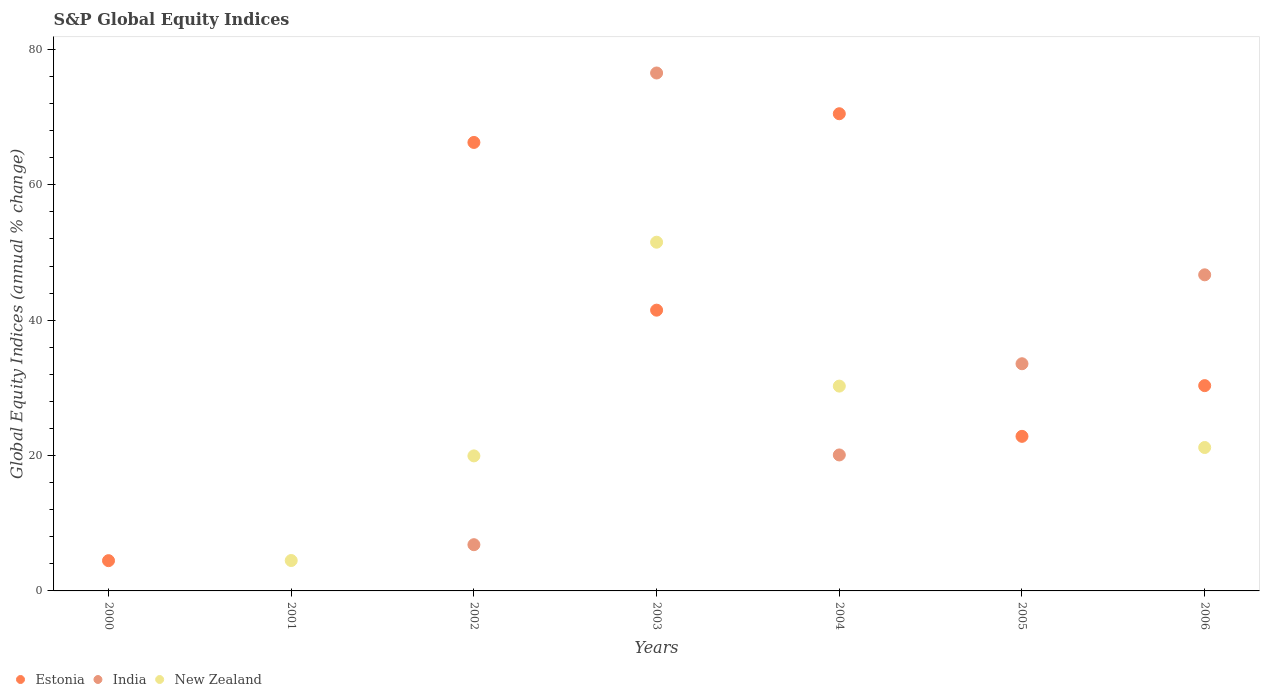Is the number of dotlines equal to the number of legend labels?
Your answer should be compact. No. What is the global equity indices in Estonia in 2005?
Keep it short and to the point. 22.84. Across all years, what is the maximum global equity indices in India?
Provide a succinct answer. 76.52. In which year was the global equity indices in Estonia maximum?
Your answer should be compact. 2004. What is the total global equity indices in Estonia in the graph?
Offer a very short reply. 235.88. What is the difference between the global equity indices in Estonia in 2003 and that in 2006?
Give a very brief answer. 11.15. What is the difference between the global equity indices in New Zealand in 2002 and the global equity indices in India in 2000?
Provide a succinct answer. 19.95. What is the average global equity indices in India per year?
Offer a very short reply. 26.24. In the year 2003, what is the difference between the global equity indices in New Zealand and global equity indices in India?
Offer a terse response. -25. What is the ratio of the global equity indices in Estonia in 2002 to that in 2004?
Give a very brief answer. 0.94. Is the difference between the global equity indices in New Zealand in 2002 and 2003 greater than the difference between the global equity indices in India in 2002 and 2003?
Offer a terse response. Yes. What is the difference between the highest and the second highest global equity indices in India?
Keep it short and to the point. 29.82. What is the difference between the highest and the lowest global equity indices in New Zealand?
Give a very brief answer. 51.52. Does the global equity indices in Estonia monotonically increase over the years?
Make the answer very short. No. Is the global equity indices in India strictly greater than the global equity indices in Estonia over the years?
Make the answer very short. No. Is the global equity indices in Estonia strictly less than the global equity indices in New Zealand over the years?
Your answer should be compact. No. How many dotlines are there?
Your response must be concise. 3. How many years are there in the graph?
Your answer should be compact. 7. Are the values on the major ticks of Y-axis written in scientific E-notation?
Provide a short and direct response. No. Does the graph contain grids?
Your answer should be very brief. No. What is the title of the graph?
Your response must be concise. S&P Global Equity Indices. What is the label or title of the X-axis?
Provide a short and direct response. Years. What is the label or title of the Y-axis?
Your answer should be compact. Global Equity Indices (annual % change). What is the Global Equity Indices (annual % change) of Estonia in 2000?
Ensure brevity in your answer.  4.47. What is the Global Equity Indices (annual % change) of India in 2000?
Ensure brevity in your answer.  0. What is the Global Equity Indices (annual % change) in New Zealand in 2000?
Ensure brevity in your answer.  0. What is the Global Equity Indices (annual % change) of New Zealand in 2001?
Provide a short and direct response. 4.49. What is the Global Equity Indices (annual % change) of Estonia in 2002?
Provide a succinct answer. 66.26. What is the Global Equity Indices (annual % change) in India in 2002?
Your response must be concise. 6.83. What is the Global Equity Indices (annual % change) in New Zealand in 2002?
Keep it short and to the point. 19.95. What is the Global Equity Indices (annual % change) in Estonia in 2003?
Give a very brief answer. 41.48. What is the Global Equity Indices (annual % change) of India in 2003?
Your response must be concise. 76.52. What is the Global Equity Indices (annual % change) in New Zealand in 2003?
Offer a very short reply. 51.52. What is the Global Equity Indices (annual % change) of Estonia in 2004?
Your answer should be compact. 70.5. What is the Global Equity Indices (annual % change) of India in 2004?
Give a very brief answer. 20.09. What is the Global Equity Indices (annual % change) in New Zealand in 2004?
Your response must be concise. 30.26. What is the Global Equity Indices (annual % change) in Estonia in 2005?
Keep it short and to the point. 22.84. What is the Global Equity Indices (annual % change) in India in 2005?
Keep it short and to the point. 33.56. What is the Global Equity Indices (annual % change) of Estonia in 2006?
Offer a very short reply. 30.33. What is the Global Equity Indices (annual % change) of India in 2006?
Ensure brevity in your answer.  46.7. What is the Global Equity Indices (annual % change) in New Zealand in 2006?
Provide a succinct answer. 21.19. Across all years, what is the maximum Global Equity Indices (annual % change) of Estonia?
Ensure brevity in your answer.  70.5. Across all years, what is the maximum Global Equity Indices (annual % change) of India?
Keep it short and to the point. 76.52. Across all years, what is the maximum Global Equity Indices (annual % change) in New Zealand?
Give a very brief answer. 51.52. Across all years, what is the minimum Global Equity Indices (annual % change) of Estonia?
Offer a very short reply. 0. Across all years, what is the minimum Global Equity Indices (annual % change) in New Zealand?
Ensure brevity in your answer.  0. What is the total Global Equity Indices (annual % change) of Estonia in the graph?
Make the answer very short. 235.88. What is the total Global Equity Indices (annual % change) in India in the graph?
Your response must be concise. 183.7. What is the total Global Equity Indices (annual % change) in New Zealand in the graph?
Keep it short and to the point. 127.41. What is the difference between the Global Equity Indices (annual % change) in Estonia in 2000 and that in 2002?
Your answer should be very brief. -61.79. What is the difference between the Global Equity Indices (annual % change) of Estonia in 2000 and that in 2003?
Keep it short and to the point. -37.01. What is the difference between the Global Equity Indices (annual % change) in Estonia in 2000 and that in 2004?
Offer a terse response. -66.03. What is the difference between the Global Equity Indices (annual % change) in Estonia in 2000 and that in 2005?
Your response must be concise. -18.37. What is the difference between the Global Equity Indices (annual % change) in Estonia in 2000 and that in 2006?
Your answer should be very brief. -25.86. What is the difference between the Global Equity Indices (annual % change) of New Zealand in 2001 and that in 2002?
Your response must be concise. -15.46. What is the difference between the Global Equity Indices (annual % change) of New Zealand in 2001 and that in 2003?
Make the answer very short. -47.03. What is the difference between the Global Equity Indices (annual % change) of New Zealand in 2001 and that in 2004?
Offer a terse response. -25.77. What is the difference between the Global Equity Indices (annual % change) of New Zealand in 2001 and that in 2006?
Make the answer very short. -16.7. What is the difference between the Global Equity Indices (annual % change) of Estonia in 2002 and that in 2003?
Your answer should be compact. 24.78. What is the difference between the Global Equity Indices (annual % change) in India in 2002 and that in 2003?
Ensure brevity in your answer.  -69.69. What is the difference between the Global Equity Indices (annual % change) in New Zealand in 2002 and that in 2003?
Your answer should be compact. -31.57. What is the difference between the Global Equity Indices (annual % change) of Estonia in 2002 and that in 2004?
Offer a very short reply. -4.24. What is the difference between the Global Equity Indices (annual % change) of India in 2002 and that in 2004?
Your answer should be very brief. -13.26. What is the difference between the Global Equity Indices (annual % change) of New Zealand in 2002 and that in 2004?
Your answer should be compact. -10.31. What is the difference between the Global Equity Indices (annual % change) in Estonia in 2002 and that in 2005?
Give a very brief answer. 43.42. What is the difference between the Global Equity Indices (annual % change) in India in 2002 and that in 2005?
Ensure brevity in your answer.  -26.73. What is the difference between the Global Equity Indices (annual % change) of Estonia in 2002 and that in 2006?
Provide a succinct answer. 35.93. What is the difference between the Global Equity Indices (annual % change) of India in 2002 and that in 2006?
Ensure brevity in your answer.  -39.87. What is the difference between the Global Equity Indices (annual % change) of New Zealand in 2002 and that in 2006?
Offer a very short reply. -1.24. What is the difference between the Global Equity Indices (annual % change) of Estonia in 2003 and that in 2004?
Offer a very short reply. -29.02. What is the difference between the Global Equity Indices (annual % change) of India in 2003 and that in 2004?
Your answer should be very brief. 56.43. What is the difference between the Global Equity Indices (annual % change) in New Zealand in 2003 and that in 2004?
Your response must be concise. 21.26. What is the difference between the Global Equity Indices (annual % change) in Estonia in 2003 and that in 2005?
Give a very brief answer. 18.64. What is the difference between the Global Equity Indices (annual % change) of India in 2003 and that in 2005?
Give a very brief answer. 42.96. What is the difference between the Global Equity Indices (annual % change) of Estonia in 2003 and that in 2006?
Provide a succinct answer. 11.15. What is the difference between the Global Equity Indices (annual % change) of India in 2003 and that in 2006?
Provide a succinct answer. 29.82. What is the difference between the Global Equity Indices (annual % change) in New Zealand in 2003 and that in 2006?
Offer a very short reply. 30.33. What is the difference between the Global Equity Indices (annual % change) of Estonia in 2004 and that in 2005?
Your answer should be very brief. 47.66. What is the difference between the Global Equity Indices (annual % change) of India in 2004 and that in 2005?
Provide a succinct answer. -13.47. What is the difference between the Global Equity Indices (annual % change) of Estonia in 2004 and that in 2006?
Provide a short and direct response. 40.17. What is the difference between the Global Equity Indices (annual % change) in India in 2004 and that in 2006?
Provide a succinct answer. -26.61. What is the difference between the Global Equity Indices (annual % change) of New Zealand in 2004 and that in 2006?
Keep it short and to the point. 9.07. What is the difference between the Global Equity Indices (annual % change) of Estonia in 2005 and that in 2006?
Offer a very short reply. -7.49. What is the difference between the Global Equity Indices (annual % change) of India in 2005 and that in 2006?
Give a very brief answer. -13.14. What is the difference between the Global Equity Indices (annual % change) of Estonia in 2000 and the Global Equity Indices (annual % change) of New Zealand in 2001?
Your response must be concise. -0.02. What is the difference between the Global Equity Indices (annual % change) of Estonia in 2000 and the Global Equity Indices (annual % change) of India in 2002?
Make the answer very short. -2.36. What is the difference between the Global Equity Indices (annual % change) in Estonia in 2000 and the Global Equity Indices (annual % change) in New Zealand in 2002?
Keep it short and to the point. -15.48. What is the difference between the Global Equity Indices (annual % change) in Estonia in 2000 and the Global Equity Indices (annual % change) in India in 2003?
Provide a short and direct response. -72.05. What is the difference between the Global Equity Indices (annual % change) of Estonia in 2000 and the Global Equity Indices (annual % change) of New Zealand in 2003?
Give a very brief answer. -47.05. What is the difference between the Global Equity Indices (annual % change) of Estonia in 2000 and the Global Equity Indices (annual % change) of India in 2004?
Keep it short and to the point. -15.62. What is the difference between the Global Equity Indices (annual % change) of Estonia in 2000 and the Global Equity Indices (annual % change) of New Zealand in 2004?
Your answer should be compact. -25.79. What is the difference between the Global Equity Indices (annual % change) of Estonia in 2000 and the Global Equity Indices (annual % change) of India in 2005?
Provide a short and direct response. -29.09. What is the difference between the Global Equity Indices (annual % change) of Estonia in 2000 and the Global Equity Indices (annual % change) of India in 2006?
Offer a very short reply. -42.23. What is the difference between the Global Equity Indices (annual % change) in Estonia in 2000 and the Global Equity Indices (annual % change) in New Zealand in 2006?
Ensure brevity in your answer.  -16.72. What is the difference between the Global Equity Indices (annual % change) in Estonia in 2002 and the Global Equity Indices (annual % change) in India in 2003?
Keep it short and to the point. -10.26. What is the difference between the Global Equity Indices (annual % change) of Estonia in 2002 and the Global Equity Indices (annual % change) of New Zealand in 2003?
Ensure brevity in your answer.  14.74. What is the difference between the Global Equity Indices (annual % change) in India in 2002 and the Global Equity Indices (annual % change) in New Zealand in 2003?
Make the answer very short. -44.69. What is the difference between the Global Equity Indices (annual % change) in Estonia in 2002 and the Global Equity Indices (annual % change) in India in 2004?
Offer a very short reply. 46.17. What is the difference between the Global Equity Indices (annual % change) in Estonia in 2002 and the Global Equity Indices (annual % change) in New Zealand in 2004?
Make the answer very short. 36. What is the difference between the Global Equity Indices (annual % change) in India in 2002 and the Global Equity Indices (annual % change) in New Zealand in 2004?
Give a very brief answer. -23.43. What is the difference between the Global Equity Indices (annual % change) of Estonia in 2002 and the Global Equity Indices (annual % change) of India in 2005?
Provide a short and direct response. 32.7. What is the difference between the Global Equity Indices (annual % change) in Estonia in 2002 and the Global Equity Indices (annual % change) in India in 2006?
Give a very brief answer. 19.56. What is the difference between the Global Equity Indices (annual % change) in Estonia in 2002 and the Global Equity Indices (annual % change) in New Zealand in 2006?
Keep it short and to the point. 45.07. What is the difference between the Global Equity Indices (annual % change) of India in 2002 and the Global Equity Indices (annual % change) of New Zealand in 2006?
Your response must be concise. -14.36. What is the difference between the Global Equity Indices (annual % change) in Estonia in 2003 and the Global Equity Indices (annual % change) in India in 2004?
Make the answer very short. 21.39. What is the difference between the Global Equity Indices (annual % change) of Estonia in 2003 and the Global Equity Indices (annual % change) of New Zealand in 2004?
Offer a very short reply. 11.22. What is the difference between the Global Equity Indices (annual % change) in India in 2003 and the Global Equity Indices (annual % change) in New Zealand in 2004?
Offer a terse response. 46.26. What is the difference between the Global Equity Indices (annual % change) of Estonia in 2003 and the Global Equity Indices (annual % change) of India in 2005?
Your answer should be compact. 7.92. What is the difference between the Global Equity Indices (annual % change) in Estonia in 2003 and the Global Equity Indices (annual % change) in India in 2006?
Offer a terse response. -5.22. What is the difference between the Global Equity Indices (annual % change) of Estonia in 2003 and the Global Equity Indices (annual % change) of New Zealand in 2006?
Your answer should be very brief. 20.29. What is the difference between the Global Equity Indices (annual % change) in India in 2003 and the Global Equity Indices (annual % change) in New Zealand in 2006?
Offer a terse response. 55.33. What is the difference between the Global Equity Indices (annual % change) in Estonia in 2004 and the Global Equity Indices (annual % change) in India in 2005?
Give a very brief answer. 36.94. What is the difference between the Global Equity Indices (annual % change) in Estonia in 2004 and the Global Equity Indices (annual % change) in India in 2006?
Offer a very short reply. 23.8. What is the difference between the Global Equity Indices (annual % change) in Estonia in 2004 and the Global Equity Indices (annual % change) in New Zealand in 2006?
Provide a short and direct response. 49.31. What is the difference between the Global Equity Indices (annual % change) of India in 2004 and the Global Equity Indices (annual % change) of New Zealand in 2006?
Your answer should be compact. -1.1. What is the difference between the Global Equity Indices (annual % change) in Estonia in 2005 and the Global Equity Indices (annual % change) in India in 2006?
Provide a succinct answer. -23.86. What is the difference between the Global Equity Indices (annual % change) in Estonia in 2005 and the Global Equity Indices (annual % change) in New Zealand in 2006?
Keep it short and to the point. 1.65. What is the difference between the Global Equity Indices (annual % change) of India in 2005 and the Global Equity Indices (annual % change) of New Zealand in 2006?
Your answer should be compact. 12.37. What is the average Global Equity Indices (annual % change) in Estonia per year?
Your response must be concise. 33.7. What is the average Global Equity Indices (annual % change) in India per year?
Make the answer very short. 26.24. What is the average Global Equity Indices (annual % change) in New Zealand per year?
Your answer should be very brief. 18.2. In the year 2002, what is the difference between the Global Equity Indices (annual % change) of Estonia and Global Equity Indices (annual % change) of India?
Your answer should be very brief. 59.43. In the year 2002, what is the difference between the Global Equity Indices (annual % change) of Estonia and Global Equity Indices (annual % change) of New Zealand?
Provide a short and direct response. 46.31. In the year 2002, what is the difference between the Global Equity Indices (annual % change) of India and Global Equity Indices (annual % change) of New Zealand?
Provide a succinct answer. -13.12. In the year 2003, what is the difference between the Global Equity Indices (annual % change) in Estonia and Global Equity Indices (annual % change) in India?
Make the answer very short. -35.04. In the year 2003, what is the difference between the Global Equity Indices (annual % change) of Estonia and Global Equity Indices (annual % change) of New Zealand?
Your answer should be compact. -10.04. In the year 2003, what is the difference between the Global Equity Indices (annual % change) of India and Global Equity Indices (annual % change) of New Zealand?
Provide a short and direct response. 25. In the year 2004, what is the difference between the Global Equity Indices (annual % change) in Estonia and Global Equity Indices (annual % change) in India?
Provide a succinct answer. 50.41. In the year 2004, what is the difference between the Global Equity Indices (annual % change) of Estonia and Global Equity Indices (annual % change) of New Zealand?
Provide a succinct answer. 40.24. In the year 2004, what is the difference between the Global Equity Indices (annual % change) in India and Global Equity Indices (annual % change) in New Zealand?
Your response must be concise. -10.17. In the year 2005, what is the difference between the Global Equity Indices (annual % change) of Estonia and Global Equity Indices (annual % change) of India?
Keep it short and to the point. -10.73. In the year 2006, what is the difference between the Global Equity Indices (annual % change) in Estonia and Global Equity Indices (annual % change) in India?
Provide a short and direct response. -16.37. In the year 2006, what is the difference between the Global Equity Indices (annual % change) in Estonia and Global Equity Indices (annual % change) in New Zealand?
Make the answer very short. 9.14. In the year 2006, what is the difference between the Global Equity Indices (annual % change) of India and Global Equity Indices (annual % change) of New Zealand?
Your response must be concise. 25.51. What is the ratio of the Global Equity Indices (annual % change) of Estonia in 2000 to that in 2002?
Provide a succinct answer. 0.07. What is the ratio of the Global Equity Indices (annual % change) of Estonia in 2000 to that in 2003?
Make the answer very short. 0.11. What is the ratio of the Global Equity Indices (annual % change) in Estonia in 2000 to that in 2004?
Provide a succinct answer. 0.06. What is the ratio of the Global Equity Indices (annual % change) in Estonia in 2000 to that in 2005?
Your answer should be very brief. 0.2. What is the ratio of the Global Equity Indices (annual % change) in Estonia in 2000 to that in 2006?
Provide a short and direct response. 0.15. What is the ratio of the Global Equity Indices (annual % change) in New Zealand in 2001 to that in 2002?
Provide a short and direct response. 0.23. What is the ratio of the Global Equity Indices (annual % change) of New Zealand in 2001 to that in 2003?
Keep it short and to the point. 0.09. What is the ratio of the Global Equity Indices (annual % change) of New Zealand in 2001 to that in 2004?
Provide a succinct answer. 0.15. What is the ratio of the Global Equity Indices (annual % change) of New Zealand in 2001 to that in 2006?
Offer a terse response. 0.21. What is the ratio of the Global Equity Indices (annual % change) of Estonia in 2002 to that in 2003?
Your answer should be compact. 1.6. What is the ratio of the Global Equity Indices (annual % change) in India in 2002 to that in 2003?
Offer a very short reply. 0.09. What is the ratio of the Global Equity Indices (annual % change) in New Zealand in 2002 to that in 2003?
Keep it short and to the point. 0.39. What is the ratio of the Global Equity Indices (annual % change) of Estonia in 2002 to that in 2004?
Offer a terse response. 0.94. What is the ratio of the Global Equity Indices (annual % change) in India in 2002 to that in 2004?
Give a very brief answer. 0.34. What is the ratio of the Global Equity Indices (annual % change) of New Zealand in 2002 to that in 2004?
Make the answer very short. 0.66. What is the ratio of the Global Equity Indices (annual % change) of Estonia in 2002 to that in 2005?
Give a very brief answer. 2.9. What is the ratio of the Global Equity Indices (annual % change) of India in 2002 to that in 2005?
Keep it short and to the point. 0.2. What is the ratio of the Global Equity Indices (annual % change) in Estonia in 2002 to that in 2006?
Your response must be concise. 2.18. What is the ratio of the Global Equity Indices (annual % change) of India in 2002 to that in 2006?
Make the answer very short. 0.15. What is the ratio of the Global Equity Indices (annual % change) in New Zealand in 2002 to that in 2006?
Offer a terse response. 0.94. What is the ratio of the Global Equity Indices (annual % change) in Estonia in 2003 to that in 2004?
Provide a succinct answer. 0.59. What is the ratio of the Global Equity Indices (annual % change) in India in 2003 to that in 2004?
Offer a terse response. 3.81. What is the ratio of the Global Equity Indices (annual % change) of New Zealand in 2003 to that in 2004?
Give a very brief answer. 1.7. What is the ratio of the Global Equity Indices (annual % change) in Estonia in 2003 to that in 2005?
Keep it short and to the point. 1.82. What is the ratio of the Global Equity Indices (annual % change) of India in 2003 to that in 2005?
Offer a very short reply. 2.28. What is the ratio of the Global Equity Indices (annual % change) in Estonia in 2003 to that in 2006?
Keep it short and to the point. 1.37. What is the ratio of the Global Equity Indices (annual % change) of India in 2003 to that in 2006?
Keep it short and to the point. 1.64. What is the ratio of the Global Equity Indices (annual % change) of New Zealand in 2003 to that in 2006?
Your response must be concise. 2.43. What is the ratio of the Global Equity Indices (annual % change) of Estonia in 2004 to that in 2005?
Offer a very short reply. 3.09. What is the ratio of the Global Equity Indices (annual % change) of India in 2004 to that in 2005?
Provide a short and direct response. 0.6. What is the ratio of the Global Equity Indices (annual % change) in Estonia in 2004 to that in 2006?
Make the answer very short. 2.32. What is the ratio of the Global Equity Indices (annual % change) in India in 2004 to that in 2006?
Provide a succinct answer. 0.43. What is the ratio of the Global Equity Indices (annual % change) of New Zealand in 2004 to that in 2006?
Ensure brevity in your answer.  1.43. What is the ratio of the Global Equity Indices (annual % change) in Estonia in 2005 to that in 2006?
Offer a terse response. 0.75. What is the ratio of the Global Equity Indices (annual % change) of India in 2005 to that in 2006?
Offer a very short reply. 0.72. What is the difference between the highest and the second highest Global Equity Indices (annual % change) of Estonia?
Give a very brief answer. 4.24. What is the difference between the highest and the second highest Global Equity Indices (annual % change) in India?
Your answer should be very brief. 29.82. What is the difference between the highest and the second highest Global Equity Indices (annual % change) of New Zealand?
Your answer should be very brief. 21.26. What is the difference between the highest and the lowest Global Equity Indices (annual % change) of Estonia?
Offer a very short reply. 70.5. What is the difference between the highest and the lowest Global Equity Indices (annual % change) of India?
Make the answer very short. 76.52. What is the difference between the highest and the lowest Global Equity Indices (annual % change) of New Zealand?
Provide a short and direct response. 51.52. 